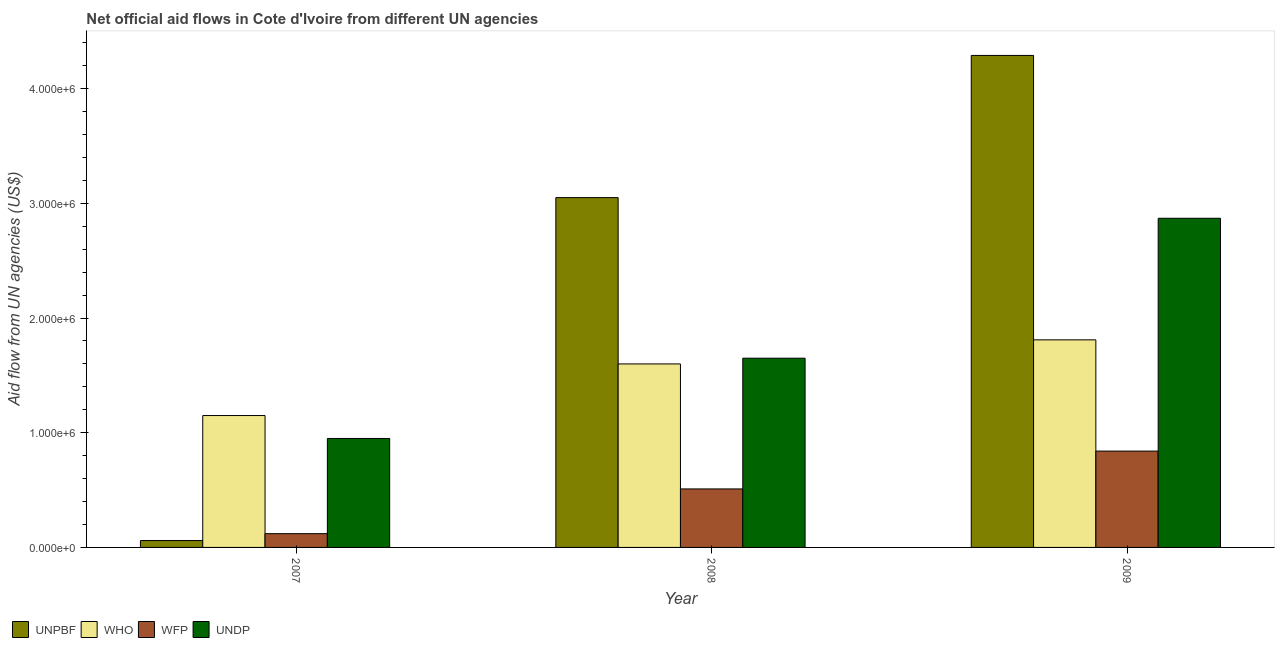How many different coloured bars are there?
Offer a terse response. 4. How many groups of bars are there?
Keep it short and to the point. 3. Are the number of bars per tick equal to the number of legend labels?
Your response must be concise. Yes. How many bars are there on the 1st tick from the right?
Make the answer very short. 4. What is the label of the 2nd group of bars from the left?
Make the answer very short. 2008. In how many cases, is the number of bars for a given year not equal to the number of legend labels?
Provide a short and direct response. 0. What is the amount of aid given by who in 2009?
Ensure brevity in your answer.  1.81e+06. Across all years, what is the maximum amount of aid given by undp?
Your answer should be very brief. 2.87e+06. Across all years, what is the minimum amount of aid given by undp?
Give a very brief answer. 9.50e+05. In which year was the amount of aid given by wfp maximum?
Your answer should be very brief. 2009. What is the total amount of aid given by wfp in the graph?
Provide a short and direct response. 1.47e+06. What is the difference between the amount of aid given by wfp in 2007 and that in 2008?
Make the answer very short. -3.90e+05. What is the difference between the amount of aid given by wfp in 2009 and the amount of aid given by unpbf in 2007?
Give a very brief answer. 7.20e+05. What is the average amount of aid given by undp per year?
Your answer should be compact. 1.82e+06. In how many years, is the amount of aid given by wfp greater than 1800000 US$?
Your answer should be compact. 0. What is the ratio of the amount of aid given by undp in 2007 to that in 2008?
Your response must be concise. 0.58. Is the difference between the amount of aid given by who in 2007 and 2009 greater than the difference between the amount of aid given by undp in 2007 and 2009?
Your answer should be very brief. No. What is the difference between the highest and the lowest amount of aid given by undp?
Offer a terse response. 1.92e+06. Is the sum of the amount of aid given by unpbf in 2008 and 2009 greater than the maximum amount of aid given by who across all years?
Keep it short and to the point. Yes. Is it the case that in every year, the sum of the amount of aid given by who and amount of aid given by unpbf is greater than the sum of amount of aid given by wfp and amount of aid given by undp?
Provide a succinct answer. No. What does the 2nd bar from the left in 2007 represents?
Your answer should be compact. WHO. What does the 1st bar from the right in 2009 represents?
Provide a succinct answer. UNDP. Are all the bars in the graph horizontal?
Make the answer very short. No. How many years are there in the graph?
Your answer should be very brief. 3. Are the values on the major ticks of Y-axis written in scientific E-notation?
Ensure brevity in your answer.  Yes. Does the graph contain grids?
Your response must be concise. No. Where does the legend appear in the graph?
Your answer should be compact. Bottom left. How are the legend labels stacked?
Offer a very short reply. Horizontal. What is the title of the graph?
Offer a very short reply. Net official aid flows in Cote d'Ivoire from different UN agencies. Does "Compensation of employees" appear as one of the legend labels in the graph?
Ensure brevity in your answer.  No. What is the label or title of the X-axis?
Offer a terse response. Year. What is the label or title of the Y-axis?
Keep it short and to the point. Aid flow from UN agencies (US$). What is the Aid flow from UN agencies (US$) of WHO in 2007?
Offer a very short reply. 1.15e+06. What is the Aid flow from UN agencies (US$) of WFP in 2007?
Ensure brevity in your answer.  1.20e+05. What is the Aid flow from UN agencies (US$) in UNDP in 2007?
Ensure brevity in your answer.  9.50e+05. What is the Aid flow from UN agencies (US$) in UNPBF in 2008?
Keep it short and to the point. 3.05e+06. What is the Aid flow from UN agencies (US$) of WHO in 2008?
Your response must be concise. 1.60e+06. What is the Aid flow from UN agencies (US$) in WFP in 2008?
Your response must be concise. 5.10e+05. What is the Aid flow from UN agencies (US$) in UNDP in 2008?
Keep it short and to the point. 1.65e+06. What is the Aid flow from UN agencies (US$) in UNPBF in 2009?
Offer a terse response. 4.29e+06. What is the Aid flow from UN agencies (US$) in WHO in 2009?
Keep it short and to the point. 1.81e+06. What is the Aid flow from UN agencies (US$) of WFP in 2009?
Keep it short and to the point. 8.40e+05. What is the Aid flow from UN agencies (US$) in UNDP in 2009?
Your answer should be very brief. 2.87e+06. Across all years, what is the maximum Aid flow from UN agencies (US$) in UNPBF?
Your response must be concise. 4.29e+06. Across all years, what is the maximum Aid flow from UN agencies (US$) of WHO?
Keep it short and to the point. 1.81e+06. Across all years, what is the maximum Aid flow from UN agencies (US$) of WFP?
Ensure brevity in your answer.  8.40e+05. Across all years, what is the maximum Aid flow from UN agencies (US$) of UNDP?
Keep it short and to the point. 2.87e+06. Across all years, what is the minimum Aid flow from UN agencies (US$) in UNPBF?
Provide a short and direct response. 6.00e+04. Across all years, what is the minimum Aid flow from UN agencies (US$) in WHO?
Offer a very short reply. 1.15e+06. Across all years, what is the minimum Aid flow from UN agencies (US$) of WFP?
Give a very brief answer. 1.20e+05. Across all years, what is the minimum Aid flow from UN agencies (US$) of UNDP?
Offer a very short reply. 9.50e+05. What is the total Aid flow from UN agencies (US$) in UNPBF in the graph?
Offer a terse response. 7.40e+06. What is the total Aid flow from UN agencies (US$) in WHO in the graph?
Make the answer very short. 4.56e+06. What is the total Aid flow from UN agencies (US$) in WFP in the graph?
Your answer should be compact. 1.47e+06. What is the total Aid flow from UN agencies (US$) of UNDP in the graph?
Keep it short and to the point. 5.47e+06. What is the difference between the Aid flow from UN agencies (US$) of UNPBF in 2007 and that in 2008?
Your answer should be compact. -2.99e+06. What is the difference between the Aid flow from UN agencies (US$) of WHO in 2007 and that in 2008?
Provide a short and direct response. -4.50e+05. What is the difference between the Aid flow from UN agencies (US$) of WFP in 2007 and that in 2008?
Your answer should be compact. -3.90e+05. What is the difference between the Aid flow from UN agencies (US$) of UNDP in 2007 and that in 2008?
Give a very brief answer. -7.00e+05. What is the difference between the Aid flow from UN agencies (US$) of UNPBF in 2007 and that in 2009?
Offer a terse response. -4.23e+06. What is the difference between the Aid flow from UN agencies (US$) in WHO in 2007 and that in 2009?
Your answer should be compact. -6.60e+05. What is the difference between the Aid flow from UN agencies (US$) of WFP in 2007 and that in 2009?
Provide a succinct answer. -7.20e+05. What is the difference between the Aid flow from UN agencies (US$) in UNDP in 2007 and that in 2009?
Your answer should be compact. -1.92e+06. What is the difference between the Aid flow from UN agencies (US$) in UNPBF in 2008 and that in 2009?
Offer a terse response. -1.24e+06. What is the difference between the Aid flow from UN agencies (US$) of WFP in 2008 and that in 2009?
Ensure brevity in your answer.  -3.30e+05. What is the difference between the Aid flow from UN agencies (US$) in UNDP in 2008 and that in 2009?
Offer a terse response. -1.22e+06. What is the difference between the Aid flow from UN agencies (US$) of UNPBF in 2007 and the Aid flow from UN agencies (US$) of WHO in 2008?
Provide a short and direct response. -1.54e+06. What is the difference between the Aid flow from UN agencies (US$) in UNPBF in 2007 and the Aid flow from UN agencies (US$) in WFP in 2008?
Ensure brevity in your answer.  -4.50e+05. What is the difference between the Aid flow from UN agencies (US$) in UNPBF in 2007 and the Aid flow from UN agencies (US$) in UNDP in 2008?
Ensure brevity in your answer.  -1.59e+06. What is the difference between the Aid flow from UN agencies (US$) of WHO in 2007 and the Aid flow from UN agencies (US$) of WFP in 2008?
Make the answer very short. 6.40e+05. What is the difference between the Aid flow from UN agencies (US$) of WHO in 2007 and the Aid flow from UN agencies (US$) of UNDP in 2008?
Your answer should be compact. -5.00e+05. What is the difference between the Aid flow from UN agencies (US$) of WFP in 2007 and the Aid flow from UN agencies (US$) of UNDP in 2008?
Keep it short and to the point. -1.53e+06. What is the difference between the Aid flow from UN agencies (US$) in UNPBF in 2007 and the Aid flow from UN agencies (US$) in WHO in 2009?
Make the answer very short. -1.75e+06. What is the difference between the Aid flow from UN agencies (US$) in UNPBF in 2007 and the Aid flow from UN agencies (US$) in WFP in 2009?
Offer a terse response. -7.80e+05. What is the difference between the Aid flow from UN agencies (US$) in UNPBF in 2007 and the Aid flow from UN agencies (US$) in UNDP in 2009?
Give a very brief answer. -2.81e+06. What is the difference between the Aid flow from UN agencies (US$) in WHO in 2007 and the Aid flow from UN agencies (US$) in WFP in 2009?
Give a very brief answer. 3.10e+05. What is the difference between the Aid flow from UN agencies (US$) of WHO in 2007 and the Aid flow from UN agencies (US$) of UNDP in 2009?
Give a very brief answer. -1.72e+06. What is the difference between the Aid flow from UN agencies (US$) of WFP in 2007 and the Aid flow from UN agencies (US$) of UNDP in 2009?
Ensure brevity in your answer.  -2.75e+06. What is the difference between the Aid flow from UN agencies (US$) in UNPBF in 2008 and the Aid flow from UN agencies (US$) in WHO in 2009?
Your response must be concise. 1.24e+06. What is the difference between the Aid flow from UN agencies (US$) in UNPBF in 2008 and the Aid flow from UN agencies (US$) in WFP in 2009?
Offer a very short reply. 2.21e+06. What is the difference between the Aid flow from UN agencies (US$) of WHO in 2008 and the Aid flow from UN agencies (US$) of WFP in 2009?
Your answer should be compact. 7.60e+05. What is the difference between the Aid flow from UN agencies (US$) of WHO in 2008 and the Aid flow from UN agencies (US$) of UNDP in 2009?
Offer a very short reply. -1.27e+06. What is the difference between the Aid flow from UN agencies (US$) of WFP in 2008 and the Aid flow from UN agencies (US$) of UNDP in 2009?
Offer a very short reply. -2.36e+06. What is the average Aid flow from UN agencies (US$) of UNPBF per year?
Offer a very short reply. 2.47e+06. What is the average Aid flow from UN agencies (US$) of WHO per year?
Your response must be concise. 1.52e+06. What is the average Aid flow from UN agencies (US$) in UNDP per year?
Your answer should be compact. 1.82e+06. In the year 2007, what is the difference between the Aid flow from UN agencies (US$) in UNPBF and Aid flow from UN agencies (US$) in WHO?
Give a very brief answer. -1.09e+06. In the year 2007, what is the difference between the Aid flow from UN agencies (US$) of UNPBF and Aid flow from UN agencies (US$) of WFP?
Offer a very short reply. -6.00e+04. In the year 2007, what is the difference between the Aid flow from UN agencies (US$) in UNPBF and Aid flow from UN agencies (US$) in UNDP?
Offer a very short reply. -8.90e+05. In the year 2007, what is the difference between the Aid flow from UN agencies (US$) of WHO and Aid flow from UN agencies (US$) of WFP?
Offer a very short reply. 1.03e+06. In the year 2007, what is the difference between the Aid flow from UN agencies (US$) of WHO and Aid flow from UN agencies (US$) of UNDP?
Make the answer very short. 2.00e+05. In the year 2007, what is the difference between the Aid flow from UN agencies (US$) of WFP and Aid flow from UN agencies (US$) of UNDP?
Provide a short and direct response. -8.30e+05. In the year 2008, what is the difference between the Aid flow from UN agencies (US$) of UNPBF and Aid flow from UN agencies (US$) of WHO?
Your response must be concise. 1.45e+06. In the year 2008, what is the difference between the Aid flow from UN agencies (US$) in UNPBF and Aid flow from UN agencies (US$) in WFP?
Offer a very short reply. 2.54e+06. In the year 2008, what is the difference between the Aid flow from UN agencies (US$) of UNPBF and Aid flow from UN agencies (US$) of UNDP?
Provide a succinct answer. 1.40e+06. In the year 2008, what is the difference between the Aid flow from UN agencies (US$) of WHO and Aid flow from UN agencies (US$) of WFP?
Give a very brief answer. 1.09e+06. In the year 2008, what is the difference between the Aid flow from UN agencies (US$) in WHO and Aid flow from UN agencies (US$) in UNDP?
Give a very brief answer. -5.00e+04. In the year 2008, what is the difference between the Aid flow from UN agencies (US$) in WFP and Aid flow from UN agencies (US$) in UNDP?
Give a very brief answer. -1.14e+06. In the year 2009, what is the difference between the Aid flow from UN agencies (US$) in UNPBF and Aid flow from UN agencies (US$) in WHO?
Your answer should be very brief. 2.48e+06. In the year 2009, what is the difference between the Aid flow from UN agencies (US$) in UNPBF and Aid flow from UN agencies (US$) in WFP?
Keep it short and to the point. 3.45e+06. In the year 2009, what is the difference between the Aid flow from UN agencies (US$) of UNPBF and Aid flow from UN agencies (US$) of UNDP?
Keep it short and to the point. 1.42e+06. In the year 2009, what is the difference between the Aid flow from UN agencies (US$) of WHO and Aid flow from UN agencies (US$) of WFP?
Your response must be concise. 9.70e+05. In the year 2009, what is the difference between the Aid flow from UN agencies (US$) in WHO and Aid flow from UN agencies (US$) in UNDP?
Provide a succinct answer. -1.06e+06. In the year 2009, what is the difference between the Aid flow from UN agencies (US$) in WFP and Aid flow from UN agencies (US$) in UNDP?
Provide a succinct answer. -2.03e+06. What is the ratio of the Aid flow from UN agencies (US$) in UNPBF in 2007 to that in 2008?
Make the answer very short. 0.02. What is the ratio of the Aid flow from UN agencies (US$) of WHO in 2007 to that in 2008?
Provide a short and direct response. 0.72. What is the ratio of the Aid flow from UN agencies (US$) in WFP in 2007 to that in 2008?
Provide a short and direct response. 0.24. What is the ratio of the Aid flow from UN agencies (US$) in UNDP in 2007 to that in 2008?
Your answer should be compact. 0.58. What is the ratio of the Aid flow from UN agencies (US$) of UNPBF in 2007 to that in 2009?
Your answer should be compact. 0.01. What is the ratio of the Aid flow from UN agencies (US$) in WHO in 2007 to that in 2009?
Keep it short and to the point. 0.64. What is the ratio of the Aid flow from UN agencies (US$) in WFP in 2007 to that in 2009?
Provide a short and direct response. 0.14. What is the ratio of the Aid flow from UN agencies (US$) in UNDP in 2007 to that in 2009?
Make the answer very short. 0.33. What is the ratio of the Aid flow from UN agencies (US$) in UNPBF in 2008 to that in 2009?
Offer a very short reply. 0.71. What is the ratio of the Aid flow from UN agencies (US$) of WHO in 2008 to that in 2009?
Make the answer very short. 0.88. What is the ratio of the Aid flow from UN agencies (US$) in WFP in 2008 to that in 2009?
Your answer should be very brief. 0.61. What is the ratio of the Aid flow from UN agencies (US$) of UNDP in 2008 to that in 2009?
Make the answer very short. 0.57. What is the difference between the highest and the second highest Aid flow from UN agencies (US$) of UNPBF?
Ensure brevity in your answer.  1.24e+06. What is the difference between the highest and the second highest Aid flow from UN agencies (US$) in WHO?
Your answer should be very brief. 2.10e+05. What is the difference between the highest and the second highest Aid flow from UN agencies (US$) of WFP?
Offer a terse response. 3.30e+05. What is the difference between the highest and the second highest Aid flow from UN agencies (US$) in UNDP?
Give a very brief answer. 1.22e+06. What is the difference between the highest and the lowest Aid flow from UN agencies (US$) of UNPBF?
Offer a terse response. 4.23e+06. What is the difference between the highest and the lowest Aid flow from UN agencies (US$) of WHO?
Keep it short and to the point. 6.60e+05. What is the difference between the highest and the lowest Aid flow from UN agencies (US$) in WFP?
Give a very brief answer. 7.20e+05. What is the difference between the highest and the lowest Aid flow from UN agencies (US$) in UNDP?
Your answer should be very brief. 1.92e+06. 